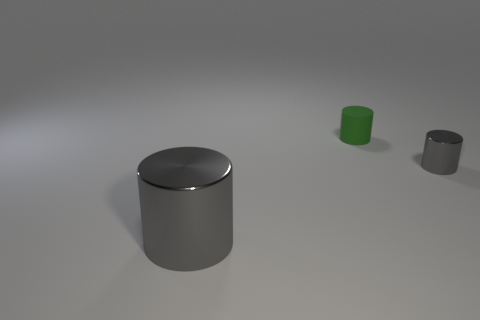There is another cylinder that is the same color as the big cylinder; what is its material?
Your answer should be compact. Metal. What is the shape of the small gray shiny thing?
Keep it short and to the point. Cylinder. Is the number of big shiny things less than the number of blue metal objects?
Your response must be concise. No. Is there any other thing that is the same size as the green cylinder?
Provide a short and direct response. Yes. There is a green object that is the same shape as the tiny gray metal object; what is it made of?
Give a very brief answer. Rubber. Is the number of tiny green rubber things greater than the number of tiny objects?
Make the answer very short. No. What number of other objects are there of the same color as the large thing?
Make the answer very short. 1. Are the small green thing and the gray cylinder in front of the small gray cylinder made of the same material?
Provide a succinct answer. No. How many green rubber cylinders are to the left of the metallic object on the left side of the small object that is right of the small green cylinder?
Provide a short and direct response. 0. Is the number of gray cylinders behind the small metal cylinder less than the number of large gray objects that are left of the big shiny thing?
Keep it short and to the point. No. 